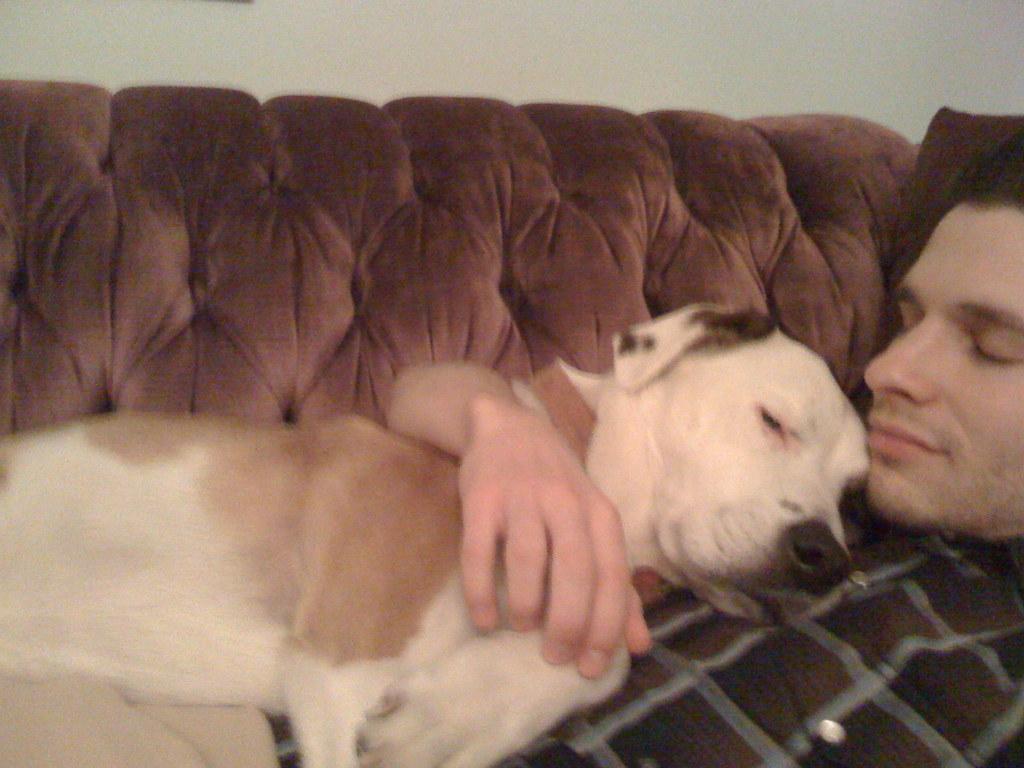Could you give a brief overview of what you see in this image? In this image we can see a man and a dog sleeping on the sofa. In the background there is a wall. 